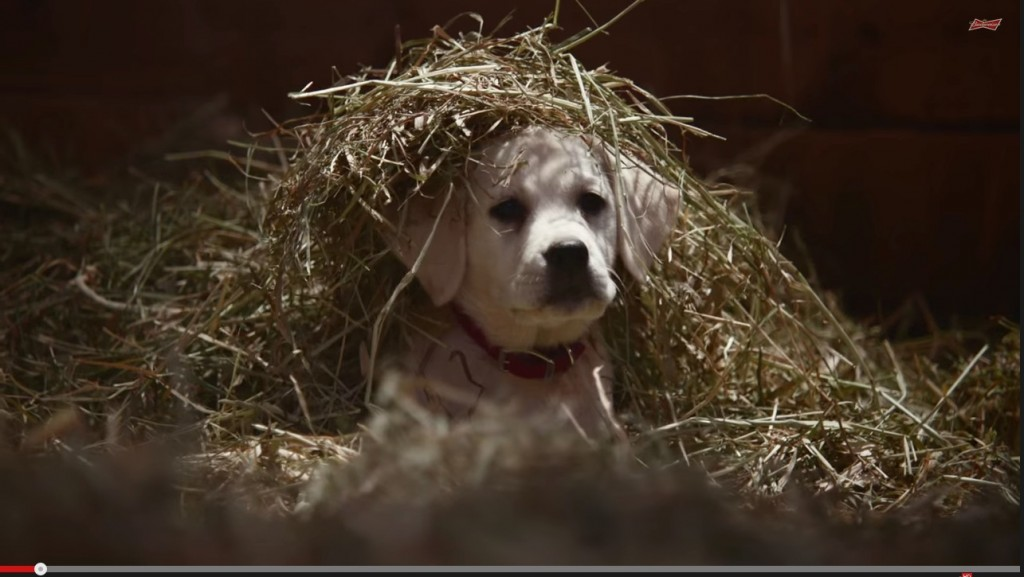What do you think the puppy is thinking about while lying under the hay? The puppy might be feeling quite content and cozy, enjoying the warmth and softness of the hay. It could also be curious about its surroundings, watching for any interesting movements or sounds. Alternatively, the puppy could simply be relaxing and feeling safe in its environment, possibly even ready for a nap. Do you think the puppy likes the feeling of hay on its head? It's very likely! Puppies are often curious and playful by nature, and the texture of the hay on its head might be intriguing and interesting to it. The fact that it seems calm and content suggests that it isn't bothered by the hay and might even find the sensation pleasant. If this puppy could write a diary entry, what would it say about this moment? Dear Diary,

Today I found myself nestled in a cozy bed of hay. It felt so soft and warm, almost like a natural blanket. Someone placed some hay gently on my head, and though it's a bit unusual, I don't mind it at all. It feels kind of funny, like wearing a hat made of nature. I feel safe and relaxed here, surrounded by the familiar smell of the barn and the gentle rustling of the hay when I move. Life is simple and sweet in moments like these. I think I'll take a nap now, dreaming of new adventures and more playful moments.

Paws and wagging tails,
The Happy Puppy 